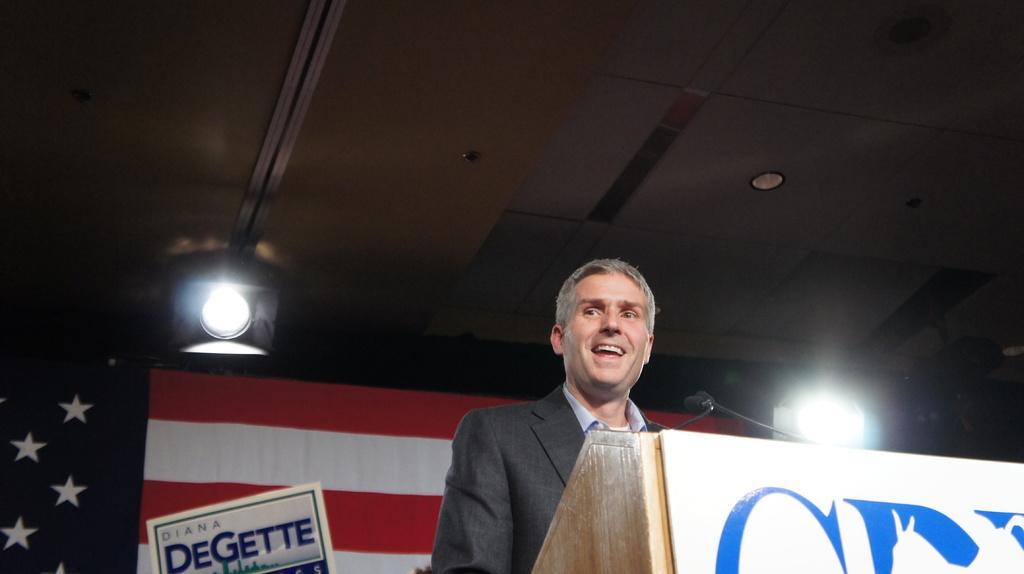Please provide a concise description of this image. In this picture I can see a podium in front and on it I can see 2 mics. Behind the podium I can see a man who is wearing formal dress and in the background I can see a flag and I can see 2 lights. On the bottom left of this picture I can see something is written. 